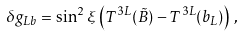<formula> <loc_0><loc_0><loc_500><loc_500>\delta g _ { L b } = \sin ^ { 2 } \xi \left ( T ^ { 3 L } ( \tilde { B } ) - T ^ { 3 L } ( b _ { L } ) \right ) \, ,</formula> 